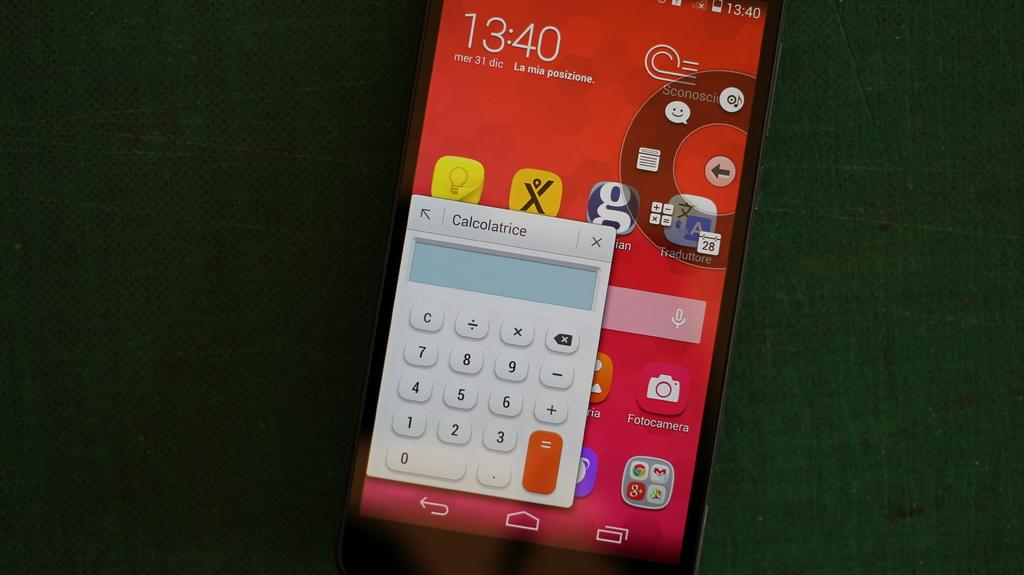What is the main subject of the image? The main subject of the image is a mobile. Where is the mobile located in the image? The mobile is on a surface in the image. What can be seen on the screen of the mobile? The mobile has apps, text, and a keypad visible on the screen. How many women are present in the image? There are no women present in the image; it features a mobile on a surface. What is the level of noise in the image? The image does not convey any information about the level of noise, as it only shows a mobile on a surface. 